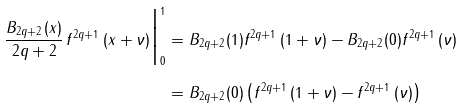<formula> <loc_0><loc_0><loc_500><loc_500>\frac { B _ { 2 q + 2 } ( x ) } { 2 q + 2 } \, f ^ { 2 q + 1 } \, ( x + \nu ) \Big | _ { 0 } ^ { 1 } & = B _ { 2 q + 2 } ( 1 ) f ^ { 2 q + 1 } \, ( 1 + \nu ) - B _ { 2 q + 2 } ( 0 ) f ^ { 2 q + 1 } \, ( \nu ) \\ & = B _ { 2 q + 2 } ( 0 ) \left ( f ^ { 2 q + 1 } \, ( 1 + \nu ) - f ^ { 2 q + 1 } \, ( \nu ) \right ) \,</formula> 